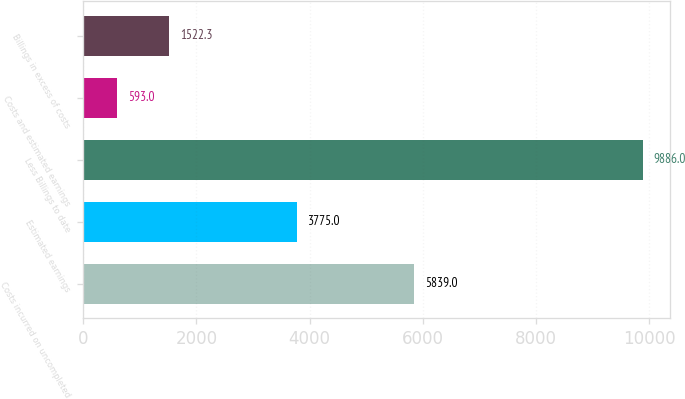Convert chart to OTSL. <chart><loc_0><loc_0><loc_500><loc_500><bar_chart><fcel>Costs incurred on uncompleted<fcel>Estimated earnings<fcel>Less Billings to date<fcel>Costs and estimated earnings<fcel>Billings in excess of costs<nl><fcel>5839<fcel>3775<fcel>9886<fcel>593<fcel>1522.3<nl></chart> 